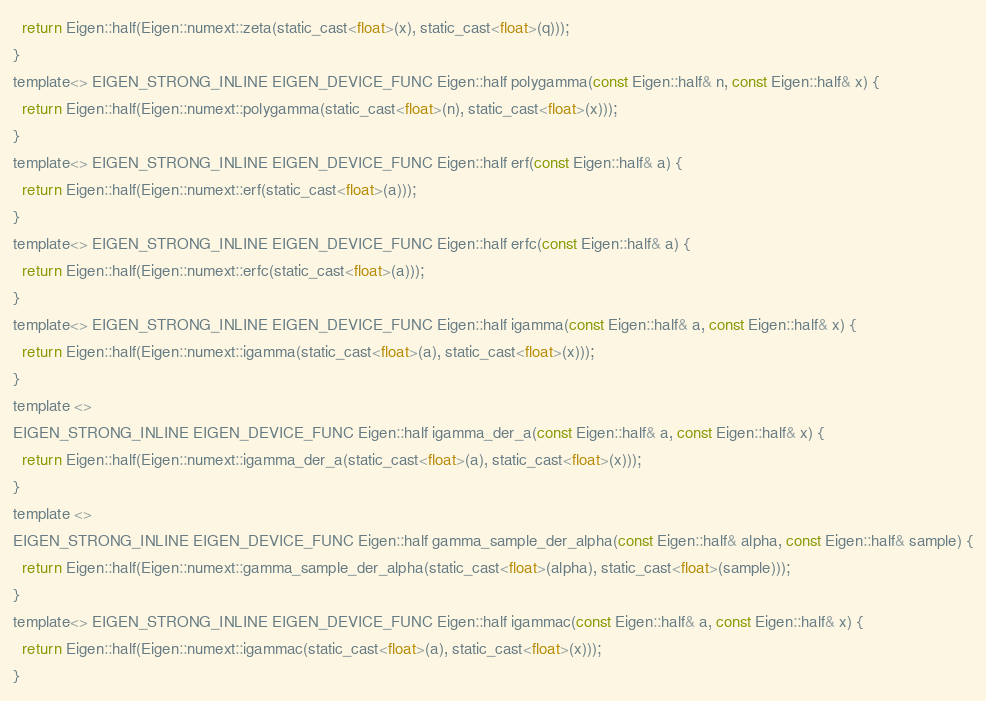<code> <loc_0><loc_0><loc_500><loc_500><_C_>  return Eigen::half(Eigen::numext::zeta(static_cast<float>(x), static_cast<float>(q)));
}
template<> EIGEN_STRONG_INLINE EIGEN_DEVICE_FUNC Eigen::half polygamma(const Eigen::half& n, const Eigen::half& x) {
  return Eigen::half(Eigen::numext::polygamma(static_cast<float>(n), static_cast<float>(x)));
}
template<> EIGEN_STRONG_INLINE EIGEN_DEVICE_FUNC Eigen::half erf(const Eigen::half& a) {
  return Eigen::half(Eigen::numext::erf(static_cast<float>(a)));
}
template<> EIGEN_STRONG_INLINE EIGEN_DEVICE_FUNC Eigen::half erfc(const Eigen::half& a) {
  return Eigen::half(Eigen::numext::erfc(static_cast<float>(a)));
}
template<> EIGEN_STRONG_INLINE EIGEN_DEVICE_FUNC Eigen::half igamma(const Eigen::half& a, const Eigen::half& x) {
  return Eigen::half(Eigen::numext::igamma(static_cast<float>(a), static_cast<float>(x)));
}
template <>
EIGEN_STRONG_INLINE EIGEN_DEVICE_FUNC Eigen::half igamma_der_a(const Eigen::half& a, const Eigen::half& x) {
  return Eigen::half(Eigen::numext::igamma_der_a(static_cast<float>(a), static_cast<float>(x)));
}
template <>
EIGEN_STRONG_INLINE EIGEN_DEVICE_FUNC Eigen::half gamma_sample_der_alpha(const Eigen::half& alpha, const Eigen::half& sample) {
  return Eigen::half(Eigen::numext::gamma_sample_der_alpha(static_cast<float>(alpha), static_cast<float>(sample)));
}
template<> EIGEN_STRONG_INLINE EIGEN_DEVICE_FUNC Eigen::half igammac(const Eigen::half& a, const Eigen::half& x) {
  return Eigen::half(Eigen::numext::igammac(static_cast<float>(a), static_cast<float>(x)));
}</code> 